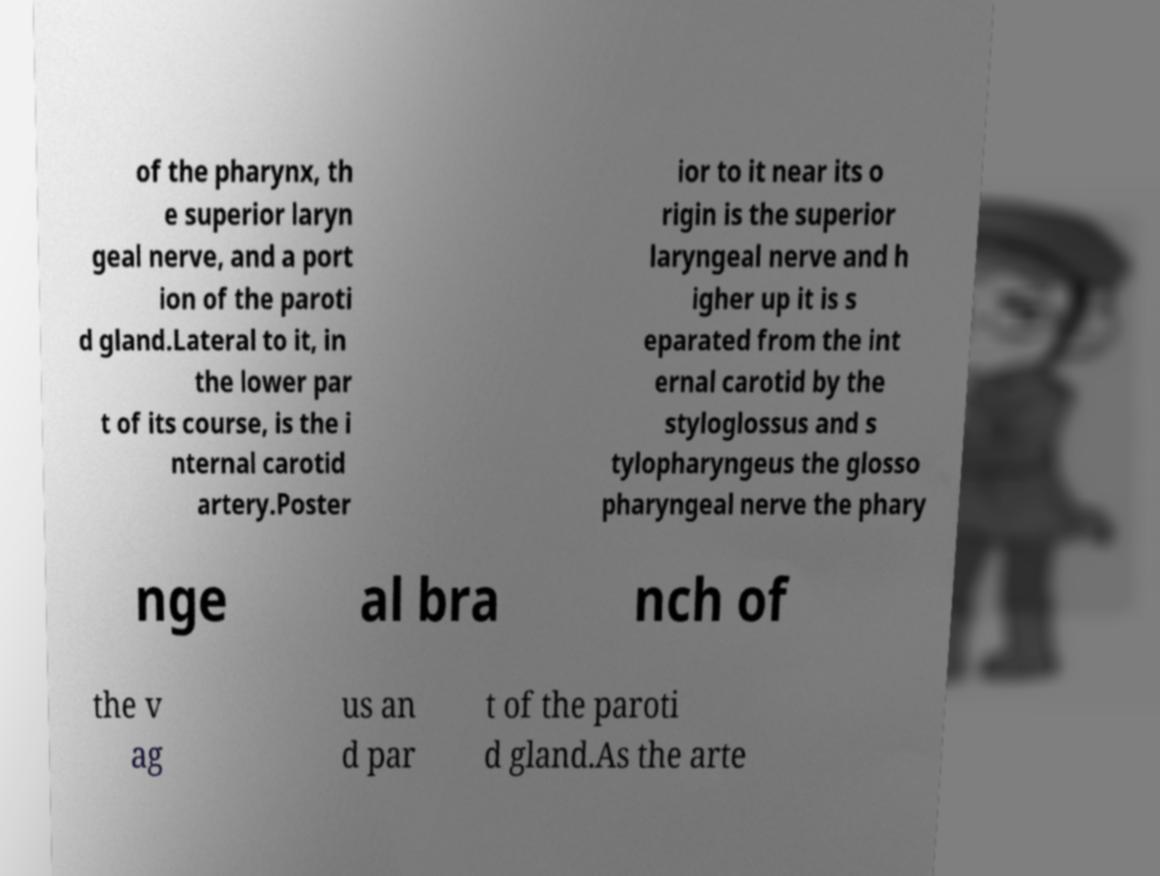There's text embedded in this image that I need extracted. Can you transcribe it verbatim? of the pharynx, th e superior laryn geal nerve, and a port ion of the paroti d gland.Lateral to it, in the lower par t of its course, is the i nternal carotid artery.Poster ior to it near its o rigin is the superior laryngeal nerve and h igher up it is s eparated from the int ernal carotid by the styloglossus and s tylopharyngeus the glosso pharyngeal nerve the phary nge al bra nch of the v ag us an d par t of the paroti d gland.As the arte 